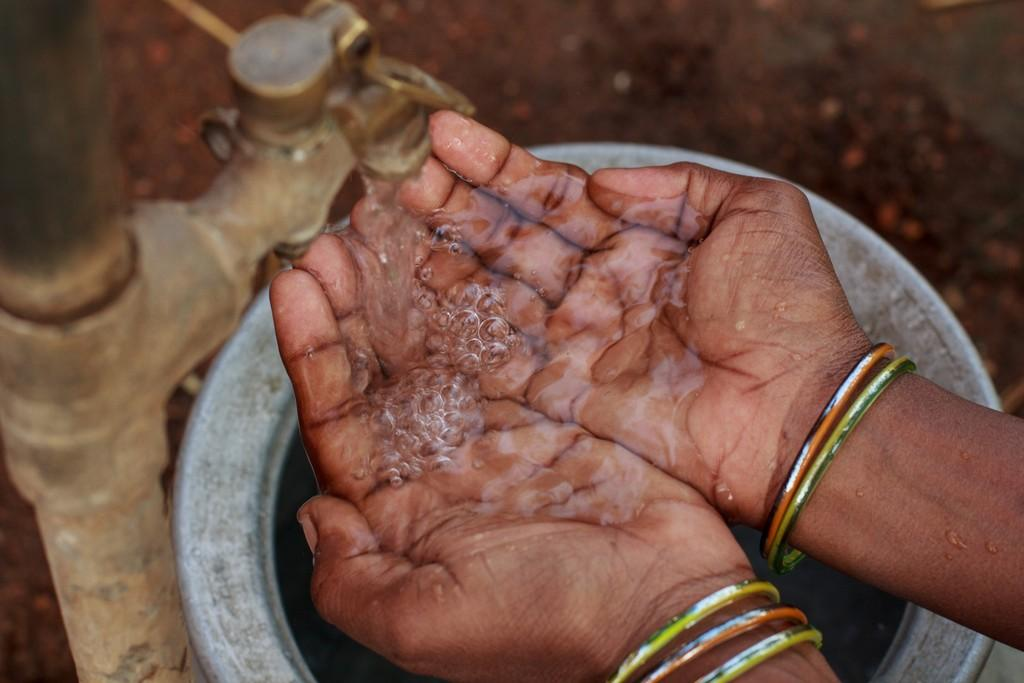What object in the image can be used to control the flow of water? There is a tap in the image that can be used to control the flow of water. What is the long, thin object in the image? There is a rod in the image. What is the liquid substance visible in the image? Water is visible in the image. Whose hands are in the image? There are a person's hands in the image. What is the person holding in the image? The person is holding a container under their hands. What type of cover is being sung by the person in the image? There is no person singing in the image, and no cover is present. What type of underwear is visible in the image? There is no underwear visible in the image. 